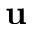Convert formula to latex. <formula><loc_0><loc_0><loc_500><loc_500>{ u }</formula> 